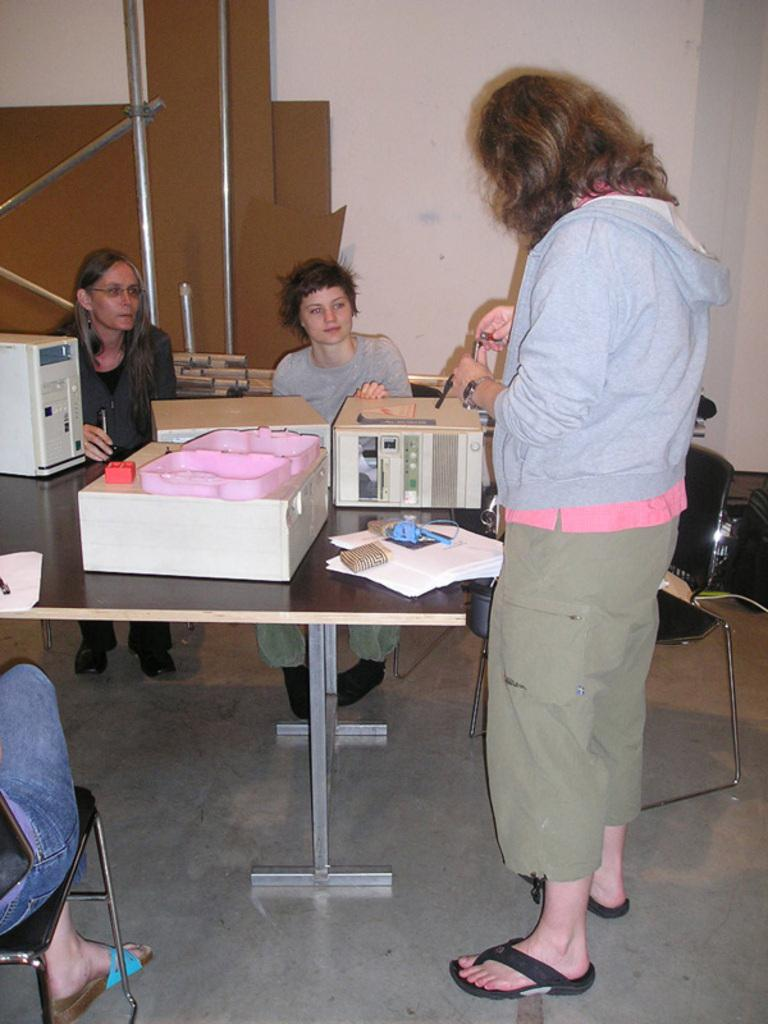What are the people in the image doing? The people in the image are sitting. Where are the people sitting in relation to the table? The people are sitting in front of a table. What can be found on the table in the image? There are objects on the table. How many baskets are visible on the table in the image? There is no information about baskets being present on the table in the image. 